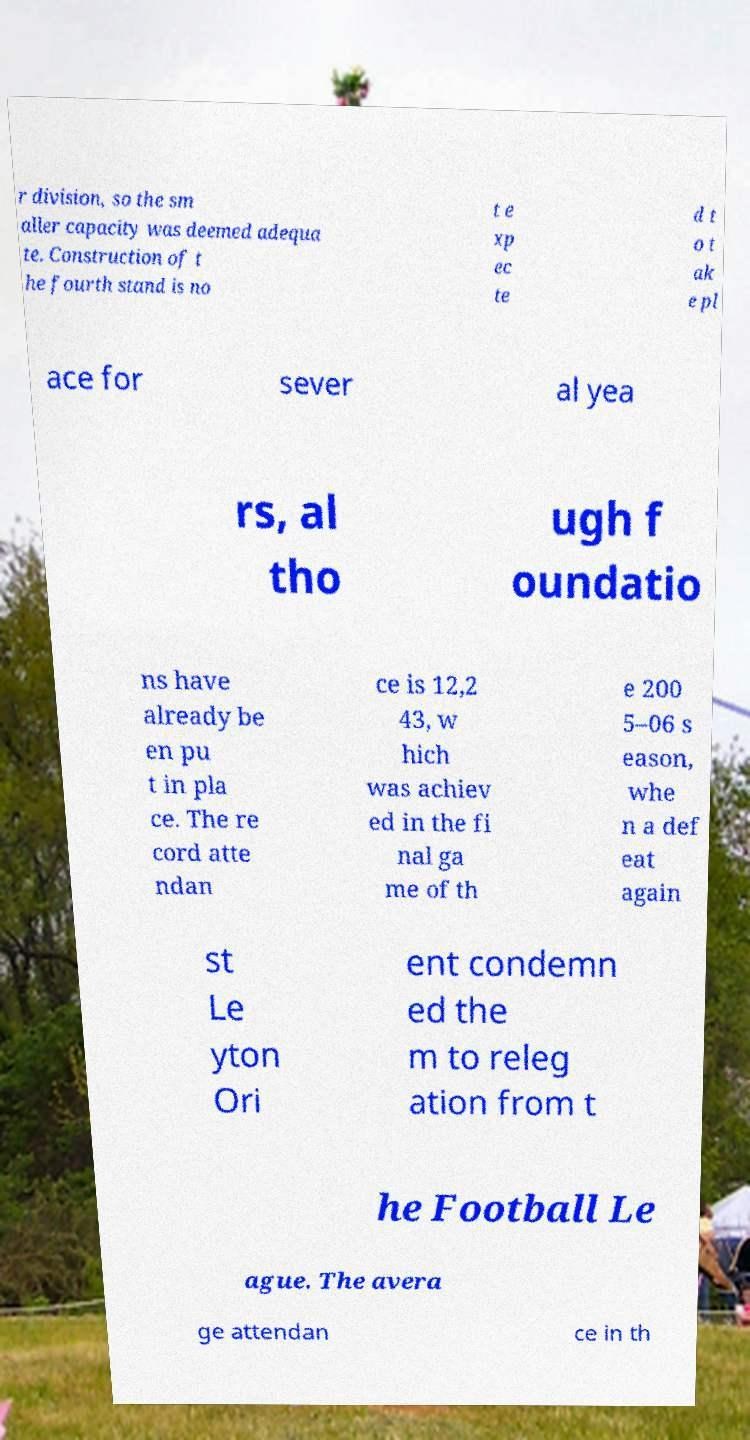Could you assist in decoding the text presented in this image and type it out clearly? r division, so the sm aller capacity was deemed adequa te. Construction of t he fourth stand is no t e xp ec te d t o t ak e pl ace for sever al yea rs, al tho ugh f oundatio ns have already be en pu t in pla ce. The re cord atte ndan ce is 12,2 43, w hich was achiev ed in the fi nal ga me of th e 200 5–06 s eason, whe n a def eat again st Le yton Ori ent condemn ed the m to releg ation from t he Football Le ague. The avera ge attendan ce in th 